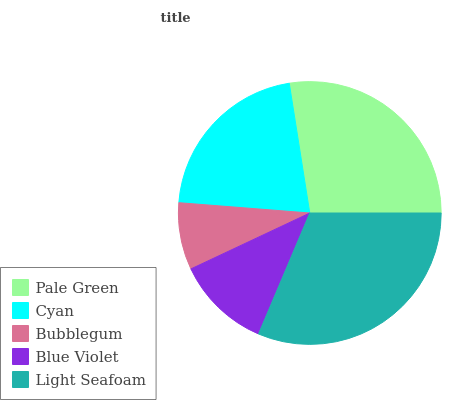Is Bubblegum the minimum?
Answer yes or no. Yes. Is Light Seafoam the maximum?
Answer yes or no. Yes. Is Cyan the minimum?
Answer yes or no. No. Is Cyan the maximum?
Answer yes or no. No. Is Pale Green greater than Cyan?
Answer yes or no. Yes. Is Cyan less than Pale Green?
Answer yes or no. Yes. Is Cyan greater than Pale Green?
Answer yes or no. No. Is Pale Green less than Cyan?
Answer yes or no. No. Is Cyan the high median?
Answer yes or no. Yes. Is Cyan the low median?
Answer yes or no. Yes. Is Pale Green the high median?
Answer yes or no. No. Is Bubblegum the low median?
Answer yes or no. No. 